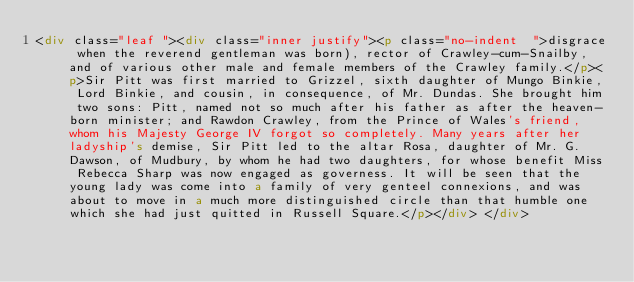<code> <loc_0><loc_0><loc_500><loc_500><_HTML_><div class="leaf "><div class="inner justify"><p class="no-indent  ">disgrace when the reverend gentleman was born), rector of Crawley-cum-Snailby, and of various other male and female members of the Crawley family.</p><p>Sir Pitt was first married to Grizzel, sixth daughter of Mungo Binkie, Lord Binkie, and cousin, in consequence, of Mr. Dundas. She brought him two sons: Pitt, named not so much after his father as after the heaven-born minister; and Rawdon Crawley, from the Prince of Wales's friend, whom his Majesty George IV forgot so completely. Many years after her ladyship's demise, Sir Pitt led to the altar Rosa, daughter of Mr. G. Dawson, of Mudbury, by whom he had two daughters, for whose benefit Miss Rebecca Sharp was now engaged as governess. It will be seen that the young lady was come into a family of very genteel connexions, and was about to move in a much more distinguished circle than that humble one which she had just quitted in Russell Square.</p></div> </div></code> 